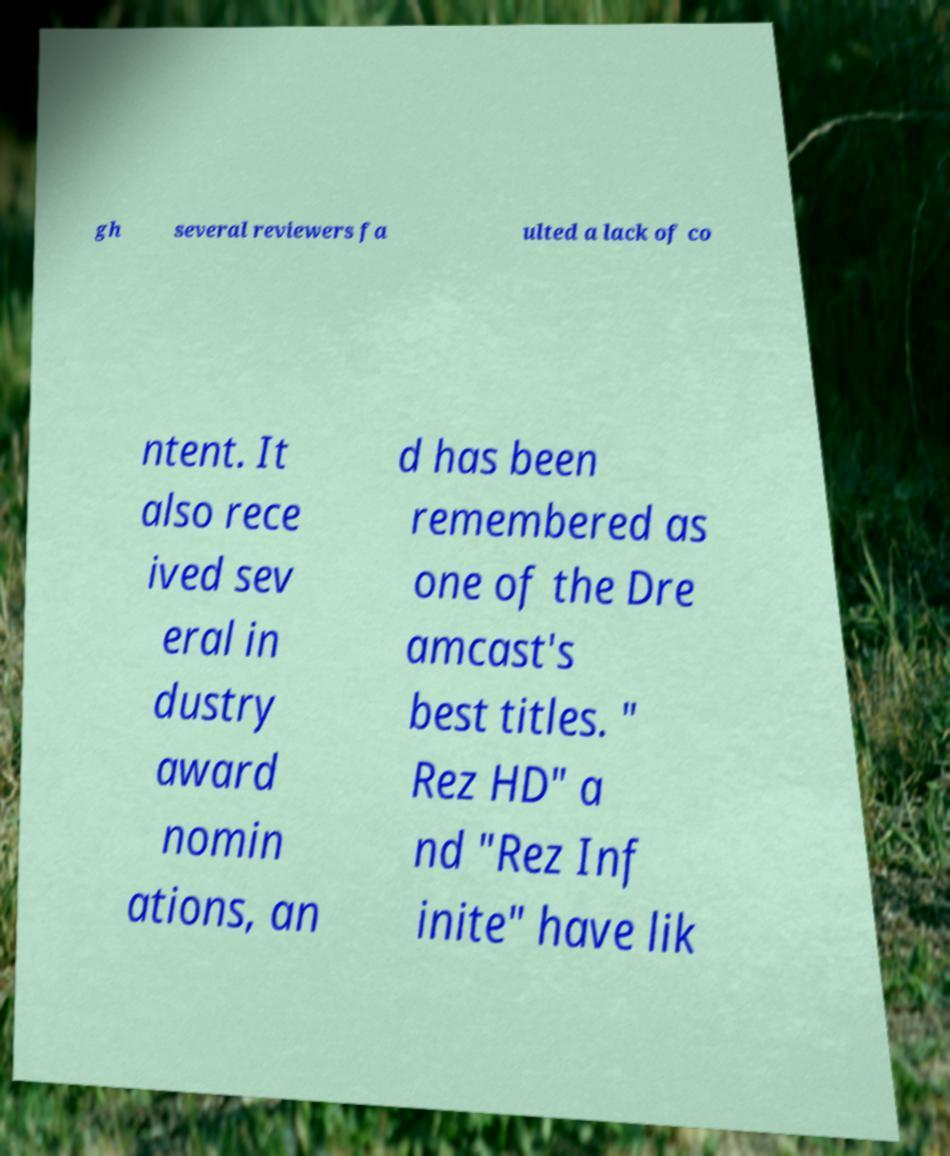There's text embedded in this image that I need extracted. Can you transcribe it verbatim? gh several reviewers fa ulted a lack of co ntent. It also rece ived sev eral in dustry award nomin ations, an d has been remembered as one of the Dre amcast's best titles. " Rez HD" a nd "Rez Inf inite" have lik 